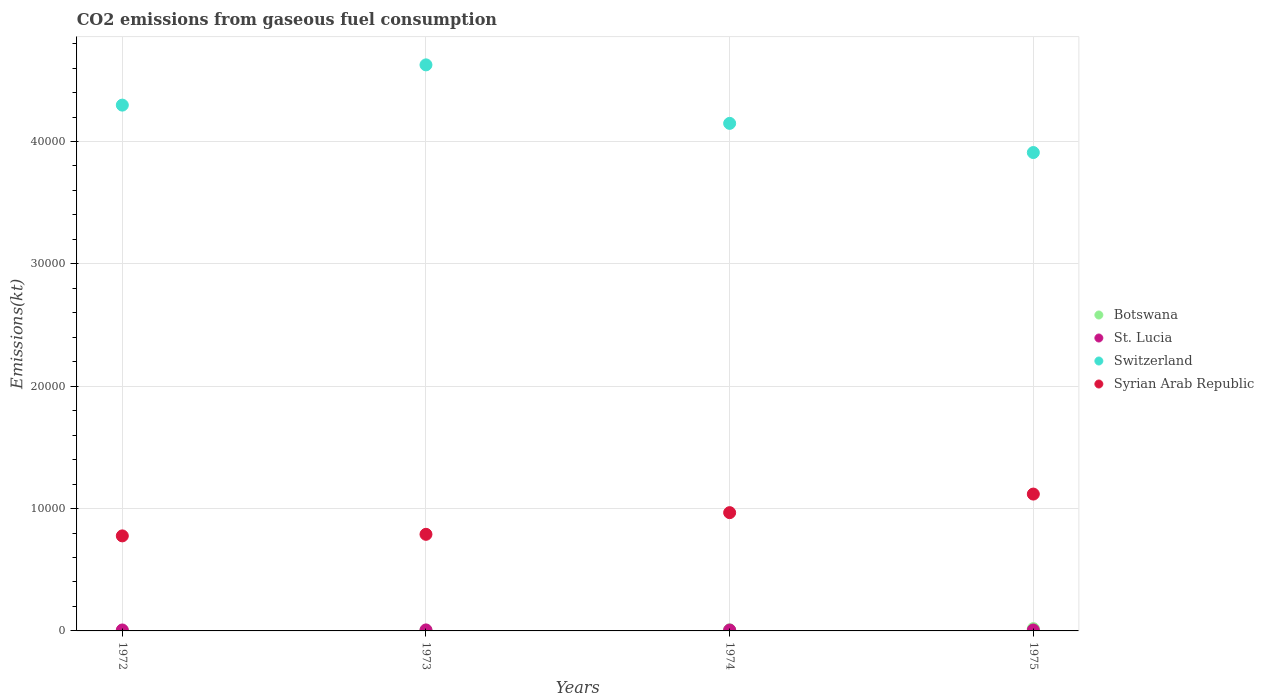What is the amount of CO2 emitted in Switzerland in 1974?
Your response must be concise. 4.15e+04. Across all years, what is the maximum amount of CO2 emitted in Switzerland?
Your response must be concise. 4.63e+04. Across all years, what is the minimum amount of CO2 emitted in Botswana?
Offer a very short reply. 22. In which year was the amount of CO2 emitted in Syrian Arab Republic maximum?
Offer a terse response. 1975. In which year was the amount of CO2 emitted in Switzerland minimum?
Offer a terse response. 1975. What is the total amount of CO2 emitted in Botswana in the graph?
Keep it short and to the point. 348.37. What is the difference between the amount of CO2 emitted in St. Lucia in 1972 and that in 1974?
Your response must be concise. 3.67. What is the difference between the amount of CO2 emitted in Switzerland in 1972 and the amount of CO2 emitted in Syrian Arab Republic in 1974?
Your answer should be very brief. 3.33e+04. What is the average amount of CO2 emitted in Syrian Arab Republic per year?
Give a very brief answer. 9128.08. In the year 1974, what is the difference between the amount of CO2 emitted in St. Lucia and amount of CO2 emitted in Switzerland?
Offer a very short reply. -4.14e+04. What is the ratio of the amount of CO2 emitted in St. Lucia in 1972 to that in 1975?
Ensure brevity in your answer.  1. Is the amount of CO2 emitted in Syrian Arab Republic in 1974 less than that in 1975?
Offer a very short reply. Yes. What is the difference between the highest and the second highest amount of CO2 emitted in Syrian Arab Republic?
Your answer should be compact. 1518.14. What is the difference between the highest and the lowest amount of CO2 emitted in Botswana?
Ensure brevity in your answer.  165.01. Is it the case that in every year, the sum of the amount of CO2 emitted in Switzerland and amount of CO2 emitted in Syrian Arab Republic  is greater than the amount of CO2 emitted in Botswana?
Your response must be concise. Yes. Is the amount of CO2 emitted in Botswana strictly greater than the amount of CO2 emitted in St. Lucia over the years?
Offer a very short reply. No. Is the amount of CO2 emitted in Switzerland strictly less than the amount of CO2 emitted in Botswana over the years?
Your answer should be very brief. No. What is the difference between two consecutive major ticks on the Y-axis?
Offer a very short reply. 10000. Are the values on the major ticks of Y-axis written in scientific E-notation?
Offer a very short reply. No. Does the graph contain grids?
Give a very brief answer. Yes. Where does the legend appear in the graph?
Your response must be concise. Center right. How many legend labels are there?
Make the answer very short. 4. What is the title of the graph?
Give a very brief answer. CO2 emissions from gaseous fuel consumption. Does "New Caledonia" appear as one of the legend labels in the graph?
Offer a very short reply. No. What is the label or title of the X-axis?
Your response must be concise. Years. What is the label or title of the Y-axis?
Your response must be concise. Emissions(kt). What is the Emissions(kt) in Botswana in 1972?
Ensure brevity in your answer.  22. What is the Emissions(kt) of St. Lucia in 1972?
Your response must be concise. 77.01. What is the Emissions(kt) in Switzerland in 1972?
Provide a short and direct response. 4.30e+04. What is the Emissions(kt) in Syrian Arab Republic in 1972?
Ensure brevity in your answer.  7766.71. What is the Emissions(kt) in Botswana in 1973?
Your answer should be very brief. 51.34. What is the Emissions(kt) of St. Lucia in 1973?
Ensure brevity in your answer.  80.67. What is the Emissions(kt) in Switzerland in 1973?
Your answer should be very brief. 4.63e+04. What is the Emissions(kt) in Syrian Arab Republic in 1973?
Your answer should be compact. 7895.05. What is the Emissions(kt) in Botswana in 1974?
Your answer should be compact. 88.01. What is the Emissions(kt) in St. Lucia in 1974?
Keep it short and to the point. 73.34. What is the Emissions(kt) in Switzerland in 1974?
Keep it short and to the point. 4.15e+04. What is the Emissions(kt) in Syrian Arab Republic in 1974?
Ensure brevity in your answer.  9666.21. What is the Emissions(kt) in Botswana in 1975?
Your response must be concise. 187.02. What is the Emissions(kt) of St. Lucia in 1975?
Provide a short and direct response. 77.01. What is the Emissions(kt) in Switzerland in 1975?
Ensure brevity in your answer.  3.91e+04. What is the Emissions(kt) in Syrian Arab Republic in 1975?
Provide a short and direct response. 1.12e+04. Across all years, what is the maximum Emissions(kt) in Botswana?
Provide a succinct answer. 187.02. Across all years, what is the maximum Emissions(kt) of St. Lucia?
Provide a short and direct response. 80.67. Across all years, what is the maximum Emissions(kt) in Switzerland?
Provide a succinct answer. 4.63e+04. Across all years, what is the maximum Emissions(kt) of Syrian Arab Republic?
Keep it short and to the point. 1.12e+04. Across all years, what is the minimum Emissions(kt) of Botswana?
Provide a succinct answer. 22. Across all years, what is the minimum Emissions(kt) in St. Lucia?
Offer a very short reply. 73.34. Across all years, what is the minimum Emissions(kt) in Switzerland?
Your response must be concise. 3.91e+04. Across all years, what is the minimum Emissions(kt) of Syrian Arab Republic?
Offer a terse response. 7766.71. What is the total Emissions(kt) in Botswana in the graph?
Give a very brief answer. 348.37. What is the total Emissions(kt) of St. Lucia in the graph?
Offer a terse response. 308.03. What is the total Emissions(kt) of Switzerland in the graph?
Your answer should be very brief. 1.70e+05. What is the total Emissions(kt) in Syrian Arab Republic in the graph?
Ensure brevity in your answer.  3.65e+04. What is the difference between the Emissions(kt) in Botswana in 1972 and that in 1973?
Provide a short and direct response. -29.34. What is the difference between the Emissions(kt) of St. Lucia in 1972 and that in 1973?
Provide a succinct answer. -3.67. What is the difference between the Emissions(kt) in Switzerland in 1972 and that in 1973?
Your response must be concise. -3289.3. What is the difference between the Emissions(kt) in Syrian Arab Republic in 1972 and that in 1973?
Offer a terse response. -128.34. What is the difference between the Emissions(kt) of Botswana in 1972 and that in 1974?
Provide a short and direct response. -66.01. What is the difference between the Emissions(kt) in St. Lucia in 1972 and that in 1974?
Provide a short and direct response. 3.67. What is the difference between the Emissions(kt) of Switzerland in 1972 and that in 1974?
Provide a short and direct response. 1492.47. What is the difference between the Emissions(kt) in Syrian Arab Republic in 1972 and that in 1974?
Your answer should be compact. -1899.51. What is the difference between the Emissions(kt) of Botswana in 1972 and that in 1975?
Provide a succinct answer. -165.01. What is the difference between the Emissions(kt) in St. Lucia in 1972 and that in 1975?
Your answer should be compact. 0. What is the difference between the Emissions(kt) of Switzerland in 1972 and that in 1975?
Provide a short and direct response. 3876.02. What is the difference between the Emissions(kt) of Syrian Arab Republic in 1972 and that in 1975?
Ensure brevity in your answer.  -3417.64. What is the difference between the Emissions(kt) of Botswana in 1973 and that in 1974?
Offer a terse response. -36.67. What is the difference between the Emissions(kt) of St. Lucia in 1973 and that in 1974?
Make the answer very short. 7.33. What is the difference between the Emissions(kt) in Switzerland in 1973 and that in 1974?
Keep it short and to the point. 4781.77. What is the difference between the Emissions(kt) in Syrian Arab Republic in 1973 and that in 1974?
Your answer should be very brief. -1771.16. What is the difference between the Emissions(kt) of Botswana in 1973 and that in 1975?
Make the answer very short. -135.68. What is the difference between the Emissions(kt) in St. Lucia in 1973 and that in 1975?
Offer a terse response. 3.67. What is the difference between the Emissions(kt) of Switzerland in 1973 and that in 1975?
Ensure brevity in your answer.  7165.32. What is the difference between the Emissions(kt) of Syrian Arab Republic in 1973 and that in 1975?
Your answer should be very brief. -3289.3. What is the difference between the Emissions(kt) in Botswana in 1974 and that in 1975?
Ensure brevity in your answer.  -99.01. What is the difference between the Emissions(kt) of St. Lucia in 1974 and that in 1975?
Your answer should be very brief. -3.67. What is the difference between the Emissions(kt) of Switzerland in 1974 and that in 1975?
Give a very brief answer. 2383.55. What is the difference between the Emissions(kt) in Syrian Arab Republic in 1974 and that in 1975?
Offer a very short reply. -1518.14. What is the difference between the Emissions(kt) of Botswana in 1972 and the Emissions(kt) of St. Lucia in 1973?
Your answer should be compact. -58.67. What is the difference between the Emissions(kt) in Botswana in 1972 and the Emissions(kt) in Switzerland in 1973?
Keep it short and to the point. -4.62e+04. What is the difference between the Emissions(kt) in Botswana in 1972 and the Emissions(kt) in Syrian Arab Republic in 1973?
Keep it short and to the point. -7873.05. What is the difference between the Emissions(kt) of St. Lucia in 1972 and the Emissions(kt) of Switzerland in 1973?
Your response must be concise. -4.62e+04. What is the difference between the Emissions(kt) in St. Lucia in 1972 and the Emissions(kt) in Syrian Arab Republic in 1973?
Provide a succinct answer. -7818.04. What is the difference between the Emissions(kt) in Switzerland in 1972 and the Emissions(kt) in Syrian Arab Republic in 1973?
Give a very brief answer. 3.51e+04. What is the difference between the Emissions(kt) of Botswana in 1972 and the Emissions(kt) of St. Lucia in 1974?
Your response must be concise. -51.34. What is the difference between the Emissions(kt) in Botswana in 1972 and the Emissions(kt) in Switzerland in 1974?
Keep it short and to the point. -4.15e+04. What is the difference between the Emissions(kt) of Botswana in 1972 and the Emissions(kt) of Syrian Arab Republic in 1974?
Keep it short and to the point. -9644.21. What is the difference between the Emissions(kt) in St. Lucia in 1972 and the Emissions(kt) in Switzerland in 1974?
Keep it short and to the point. -4.14e+04. What is the difference between the Emissions(kt) in St. Lucia in 1972 and the Emissions(kt) in Syrian Arab Republic in 1974?
Your answer should be compact. -9589.2. What is the difference between the Emissions(kt) in Switzerland in 1972 and the Emissions(kt) in Syrian Arab Republic in 1974?
Make the answer very short. 3.33e+04. What is the difference between the Emissions(kt) in Botswana in 1972 and the Emissions(kt) in St. Lucia in 1975?
Offer a very short reply. -55.01. What is the difference between the Emissions(kt) of Botswana in 1972 and the Emissions(kt) of Switzerland in 1975?
Make the answer very short. -3.91e+04. What is the difference between the Emissions(kt) in Botswana in 1972 and the Emissions(kt) in Syrian Arab Republic in 1975?
Make the answer very short. -1.12e+04. What is the difference between the Emissions(kt) in St. Lucia in 1972 and the Emissions(kt) in Switzerland in 1975?
Ensure brevity in your answer.  -3.90e+04. What is the difference between the Emissions(kt) of St. Lucia in 1972 and the Emissions(kt) of Syrian Arab Republic in 1975?
Provide a short and direct response. -1.11e+04. What is the difference between the Emissions(kt) in Switzerland in 1972 and the Emissions(kt) in Syrian Arab Republic in 1975?
Your answer should be compact. 3.18e+04. What is the difference between the Emissions(kt) in Botswana in 1973 and the Emissions(kt) in St. Lucia in 1974?
Your answer should be compact. -22. What is the difference between the Emissions(kt) of Botswana in 1973 and the Emissions(kt) of Switzerland in 1974?
Keep it short and to the point. -4.14e+04. What is the difference between the Emissions(kt) of Botswana in 1973 and the Emissions(kt) of Syrian Arab Republic in 1974?
Give a very brief answer. -9614.87. What is the difference between the Emissions(kt) in St. Lucia in 1973 and the Emissions(kt) in Switzerland in 1974?
Your response must be concise. -4.14e+04. What is the difference between the Emissions(kt) in St. Lucia in 1973 and the Emissions(kt) in Syrian Arab Republic in 1974?
Give a very brief answer. -9585.54. What is the difference between the Emissions(kt) in Switzerland in 1973 and the Emissions(kt) in Syrian Arab Republic in 1974?
Provide a short and direct response. 3.66e+04. What is the difference between the Emissions(kt) in Botswana in 1973 and the Emissions(kt) in St. Lucia in 1975?
Offer a very short reply. -25.67. What is the difference between the Emissions(kt) in Botswana in 1973 and the Emissions(kt) in Switzerland in 1975?
Ensure brevity in your answer.  -3.90e+04. What is the difference between the Emissions(kt) of Botswana in 1973 and the Emissions(kt) of Syrian Arab Republic in 1975?
Provide a succinct answer. -1.11e+04. What is the difference between the Emissions(kt) in St. Lucia in 1973 and the Emissions(kt) in Switzerland in 1975?
Give a very brief answer. -3.90e+04. What is the difference between the Emissions(kt) in St. Lucia in 1973 and the Emissions(kt) in Syrian Arab Republic in 1975?
Your response must be concise. -1.11e+04. What is the difference between the Emissions(kt) in Switzerland in 1973 and the Emissions(kt) in Syrian Arab Republic in 1975?
Offer a terse response. 3.51e+04. What is the difference between the Emissions(kt) of Botswana in 1974 and the Emissions(kt) of St. Lucia in 1975?
Your response must be concise. 11. What is the difference between the Emissions(kt) in Botswana in 1974 and the Emissions(kt) in Switzerland in 1975?
Give a very brief answer. -3.90e+04. What is the difference between the Emissions(kt) of Botswana in 1974 and the Emissions(kt) of Syrian Arab Republic in 1975?
Provide a succinct answer. -1.11e+04. What is the difference between the Emissions(kt) in St. Lucia in 1974 and the Emissions(kt) in Switzerland in 1975?
Keep it short and to the point. -3.90e+04. What is the difference between the Emissions(kt) of St. Lucia in 1974 and the Emissions(kt) of Syrian Arab Republic in 1975?
Provide a short and direct response. -1.11e+04. What is the difference between the Emissions(kt) in Switzerland in 1974 and the Emissions(kt) in Syrian Arab Republic in 1975?
Your response must be concise. 3.03e+04. What is the average Emissions(kt) of Botswana per year?
Your response must be concise. 87.09. What is the average Emissions(kt) of St. Lucia per year?
Your answer should be compact. 77.01. What is the average Emissions(kt) of Switzerland per year?
Offer a very short reply. 4.25e+04. What is the average Emissions(kt) in Syrian Arab Republic per year?
Give a very brief answer. 9128.08. In the year 1972, what is the difference between the Emissions(kt) of Botswana and Emissions(kt) of St. Lucia?
Offer a terse response. -55.01. In the year 1972, what is the difference between the Emissions(kt) in Botswana and Emissions(kt) in Switzerland?
Offer a terse response. -4.30e+04. In the year 1972, what is the difference between the Emissions(kt) of Botswana and Emissions(kt) of Syrian Arab Republic?
Give a very brief answer. -7744.7. In the year 1972, what is the difference between the Emissions(kt) in St. Lucia and Emissions(kt) in Switzerland?
Provide a succinct answer. -4.29e+04. In the year 1972, what is the difference between the Emissions(kt) of St. Lucia and Emissions(kt) of Syrian Arab Republic?
Your response must be concise. -7689.7. In the year 1972, what is the difference between the Emissions(kt) in Switzerland and Emissions(kt) in Syrian Arab Republic?
Your response must be concise. 3.52e+04. In the year 1973, what is the difference between the Emissions(kt) of Botswana and Emissions(kt) of St. Lucia?
Provide a succinct answer. -29.34. In the year 1973, what is the difference between the Emissions(kt) of Botswana and Emissions(kt) of Switzerland?
Your answer should be compact. -4.62e+04. In the year 1973, what is the difference between the Emissions(kt) in Botswana and Emissions(kt) in Syrian Arab Republic?
Your answer should be very brief. -7843.71. In the year 1973, what is the difference between the Emissions(kt) of St. Lucia and Emissions(kt) of Switzerland?
Make the answer very short. -4.62e+04. In the year 1973, what is the difference between the Emissions(kt) in St. Lucia and Emissions(kt) in Syrian Arab Republic?
Offer a very short reply. -7814.38. In the year 1973, what is the difference between the Emissions(kt) in Switzerland and Emissions(kt) in Syrian Arab Republic?
Your response must be concise. 3.84e+04. In the year 1974, what is the difference between the Emissions(kt) in Botswana and Emissions(kt) in St. Lucia?
Keep it short and to the point. 14.67. In the year 1974, what is the difference between the Emissions(kt) in Botswana and Emissions(kt) in Switzerland?
Your response must be concise. -4.14e+04. In the year 1974, what is the difference between the Emissions(kt) of Botswana and Emissions(kt) of Syrian Arab Republic?
Ensure brevity in your answer.  -9578.2. In the year 1974, what is the difference between the Emissions(kt) in St. Lucia and Emissions(kt) in Switzerland?
Keep it short and to the point. -4.14e+04. In the year 1974, what is the difference between the Emissions(kt) of St. Lucia and Emissions(kt) of Syrian Arab Republic?
Ensure brevity in your answer.  -9592.87. In the year 1974, what is the difference between the Emissions(kt) in Switzerland and Emissions(kt) in Syrian Arab Republic?
Ensure brevity in your answer.  3.18e+04. In the year 1975, what is the difference between the Emissions(kt) of Botswana and Emissions(kt) of St. Lucia?
Your answer should be very brief. 110.01. In the year 1975, what is the difference between the Emissions(kt) in Botswana and Emissions(kt) in Switzerland?
Give a very brief answer. -3.89e+04. In the year 1975, what is the difference between the Emissions(kt) of Botswana and Emissions(kt) of Syrian Arab Republic?
Give a very brief answer. -1.10e+04. In the year 1975, what is the difference between the Emissions(kt) in St. Lucia and Emissions(kt) in Switzerland?
Your answer should be very brief. -3.90e+04. In the year 1975, what is the difference between the Emissions(kt) of St. Lucia and Emissions(kt) of Syrian Arab Republic?
Keep it short and to the point. -1.11e+04. In the year 1975, what is the difference between the Emissions(kt) of Switzerland and Emissions(kt) of Syrian Arab Republic?
Offer a terse response. 2.79e+04. What is the ratio of the Emissions(kt) in Botswana in 1972 to that in 1973?
Give a very brief answer. 0.43. What is the ratio of the Emissions(kt) of St. Lucia in 1972 to that in 1973?
Provide a short and direct response. 0.95. What is the ratio of the Emissions(kt) in Switzerland in 1972 to that in 1973?
Keep it short and to the point. 0.93. What is the ratio of the Emissions(kt) of Syrian Arab Republic in 1972 to that in 1973?
Your answer should be compact. 0.98. What is the ratio of the Emissions(kt) in Botswana in 1972 to that in 1974?
Your answer should be compact. 0.25. What is the ratio of the Emissions(kt) in Switzerland in 1972 to that in 1974?
Offer a very short reply. 1.04. What is the ratio of the Emissions(kt) of Syrian Arab Republic in 1972 to that in 1974?
Your response must be concise. 0.8. What is the ratio of the Emissions(kt) of Botswana in 1972 to that in 1975?
Make the answer very short. 0.12. What is the ratio of the Emissions(kt) of Switzerland in 1972 to that in 1975?
Keep it short and to the point. 1.1. What is the ratio of the Emissions(kt) in Syrian Arab Republic in 1972 to that in 1975?
Offer a very short reply. 0.69. What is the ratio of the Emissions(kt) in Botswana in 1973 to that in 1974?
Provide a short and direct response. 0.58. What is the ratio of the Emissions(kt) of Switzerland in 1973 to that in 1974?
Your answer should be very brief. 1.12. What is the ratio of the Emissions(kt) in Syrian Arab Republic in 1973 to that in 1974?
Ensure brevity in your answer.  0.82. What is the ratio of the Emissions(kt) of Botswana in 1973 to that in 1975?
Offer a very short reply. 0.27. What is the ratio of the Emissions(kt) of St. Lucia in 1973 to that in 1975?
Your answer should be very brief. 1.05. What is the ratio of the Emissions(kt) in Switzerland in 1973 to that in 1975?
Ensure brevity in your answer.  1.18. What is the ratio of the Emissions(kt) of Syrian Arab Republic in 1973 to that in 1975?
Make the answer very short. 0.71. What is the ratio of the Emissions(kt) in Botswana in 1974 to that in 1975?
Make the answer very short. 0.47. What is the ratio of the Emissions(kt) of St. Lucia in 1974 to that in 1975?
Offer a very short reply. 0.95. What is the ratio of the Emissions(kt) in Switzerland in 1974 to that in 1975?
Make the answer very short. 1.06. What is the ratio of the Emissions(kt) of Syrian Arab Republic in 1974 to that in 1975?
Ensure brevity in your answer.  0.86. What is the difference between the highest and the second highest Emissions(kt) in Botswana?
Your answer should be very brief. 99.01. What is the difference between the highest and the second highest Emissions(kt) of St. Lucia?
Keep it short and to the point. 3.67. What is the difference between the highest and the second highest Emissions(kt) of Switzerland?
Ensure brevity in your answer.  3289.3. What is the difference between the highest and the second highest Emissions(kt) in Syrian Arab Republic?
Ensure brevity in your answer.  1518.14. What is the difference between the highest and the lowest Emissions(kt) of Botswana?
Offer a terse response. 165.01. What is the difference between the highest and the lowest Emissions(kt) in St. Lucia?
Offer a very short reply. 7.33. What is the difference between the highest and the lowest Emissions(kt) in Switzerland?
Offer a very short reply. 7165.32. What is the difference between the highest and the lowest Emissions(kt) of Syrian Arab Republic?
Your response must be concise. 3417.64. 